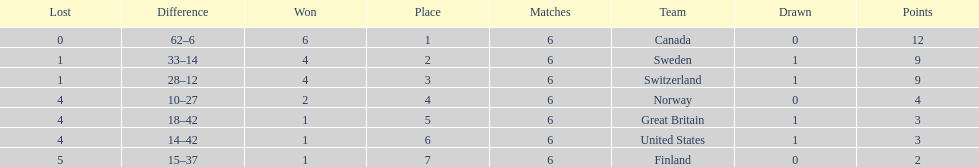How many teams won 6 matches? 1. 